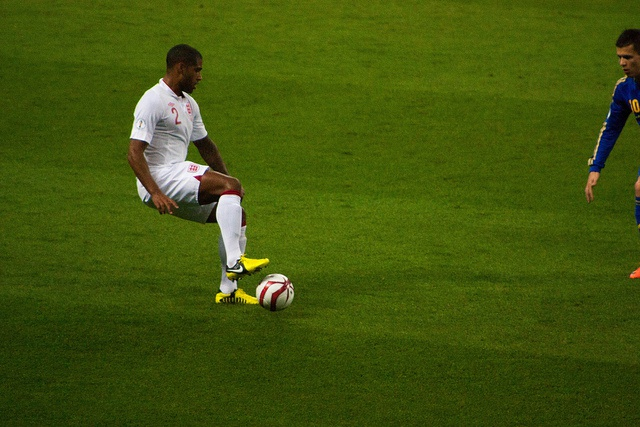Describe the objects in this image and their specific colors. I can see people in darkgreen, lightgray, black, darkgray, and maroon tones, people in darkgreen, black, and navy tones, and sports ball in darkgreen, beige, black, and maroon tones in this image. 